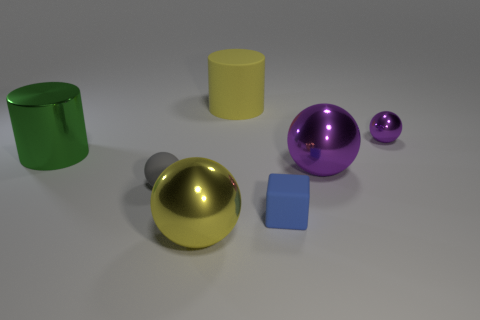Subtract 1 balls. How many balls are left? 3 Subtract all green spheres. Subtract all green cubes. How many spheres are left? 4 Add 1 tiny gray rubber balls. How many objects exist? 8 Subtract all balls. How many objects are left? 3 Subtract 1 yellow spheres. How many objects are left? 6 Subtract all tiny blue matte cubes. Subtract all small blue blocks. How many objects are left? 5 Add 1 metal things. How many metal things are left? 5 Add 3 large green metallic objects. How many large green metallic objects exist? 4 